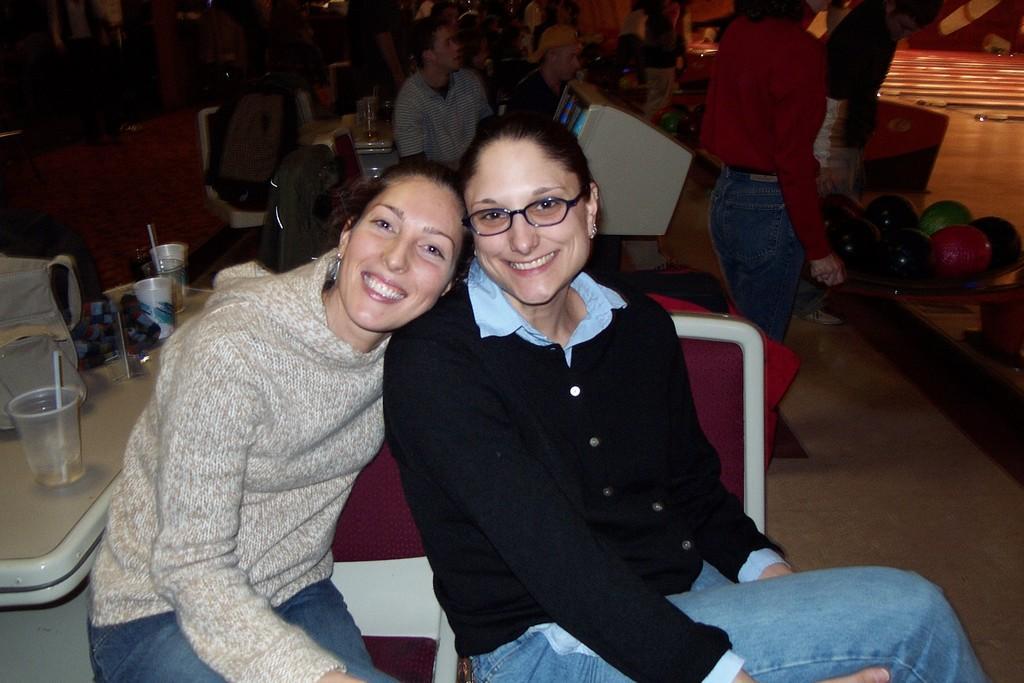Could you give a brief overview of what you see in this image? In the foreground of the image there are two ladies sitting on chairs. To the left side of the image there is a table on which there are glasses and other objects. In the background of the image there are people. To the right side of the image there are balls. At the bottom of the image there is floor. In the center of the image there is a monitor. 